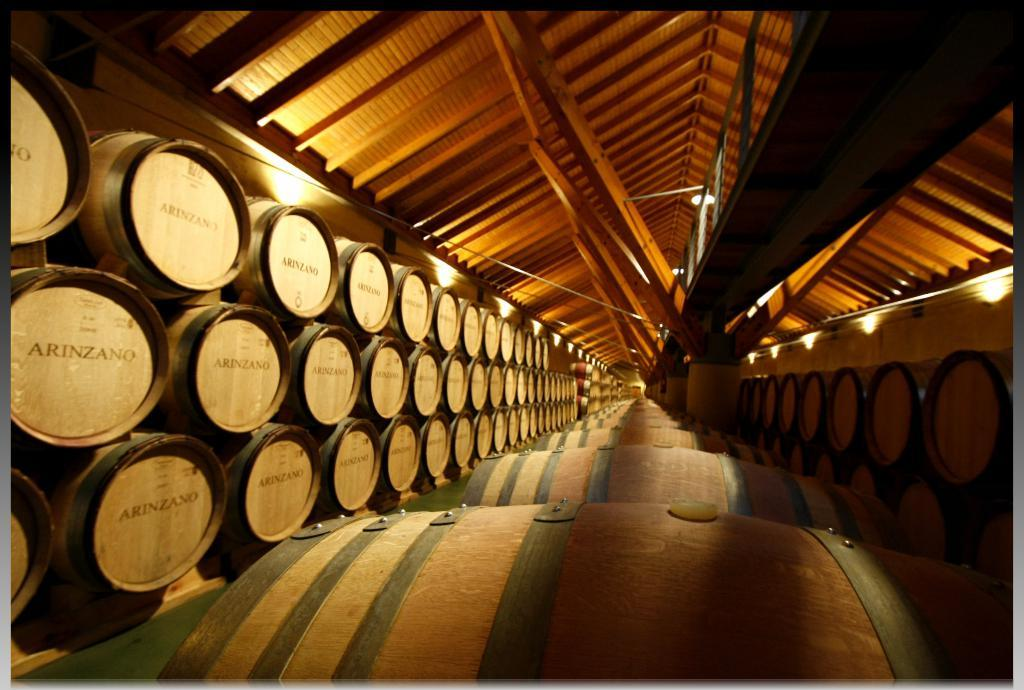<image>
Render a clear and concise summary of the photo. A large number of wooden barrels with the logo for Arinzano on thier face are lined up. 